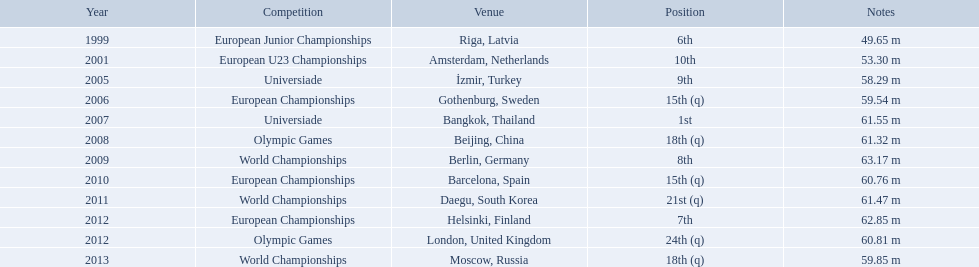What are the years listed prior to 2007? 1999, 2001, 2005, 2006. What are their corresponding finishes? 6th, 10th, 9th, 15th (q). Which is the highest? 6th. What are the years that gerhard mayer participated? 1999, 2001, 2005, 2006, 2007, 2008, 2009, 2010, 2011, 2012, 2012, 2013. Which years were earlier than 2007? 1999, 2001, 2005, 2006. What was the best placing for these years? 6th. What are all the competitions? European Junior Championships, European U23 Championships, Universiade, European Championships, Universiade, Olympic Games, World Championships, European Championships, World Championships, European Championships, Olympic Games, World Championships. What years did they place in the top 10? 1999, 2001, 2005, 2007, 2009, 2012. Besides when they placed first, which position was their highest? 6th. Would you mind parsing the complete table? {'header': ['Year', 'Competition', 'Venue', 'Position', 'Notes'], 'rows': [['1999', 'European Junior Championships', 'Riga, Latvia', '6th', '49.65 m'], ['2001', 'European U23 Championships', 'Amsterdam, Netherlands', '10th', '53.30 m'], ['2005', 'Universiade', 'İzmir, Turkey', '9th', '58.29 m'], ['2006', 'European Championships', 'Gothenburg, Sweden', '15th (q)', '59.54 m'], ['2007', 'Universiade', 'Bangkok, Thailand', '1st', '61.55 m'], ['2008', 'Olympic Games', 'Beijing, China', '18th (q)', '61.32 m'], ['2009', 'World Championships', 'Berlin, Germany', '8th', '63.17 m'], ['2010', 'European Championships', 'Barcelona, Spain', '15th (q)', '60.76 m'], ['2011', 'World Championships', 'Daegu, South Korea', '21st (q)', '61.47 m'], ['2012', 'European Championships', 'Helsinki, Finland', '7th', '62.85 m'], ['2012', 'Olympic Games', 'London, United Kingdom', '24th (q)', '60.81 m'], ['2013', 'World Championships', 'Moscow, Russia', '18th (q)', '59.85 m']]} What were the lengths of mayer's throws? 49.65 m, 53.30 m, 58.29 m, 59.54 m, 61.55 m, 61.32 m, 63.17 m, 60.76 m, 61.47 m, 62.85 m, 60.81 m, 59.85 m. Which of these had the greatest distance? 63.17 m. What european junior tournaments? 6th. What was the european junior tournaments' greatest result? 63.17 m. Which european junior championships are being referred to? 6th. What was the best outcome at a european junior championships event? 63.17 m. What specific european junior championships event is being discussed? 6th. What was the most outstanding performance in the european junior championships? 63.17 m. Which event is related to the european junior championships? 6th. What was the most remarkable result achieved in the european junior championships? 63.17 m. 